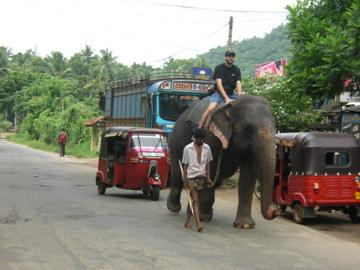The white man is most likely what?

Choices:
A) warrior
B) tourist
C) prisoner
D) native tourist 